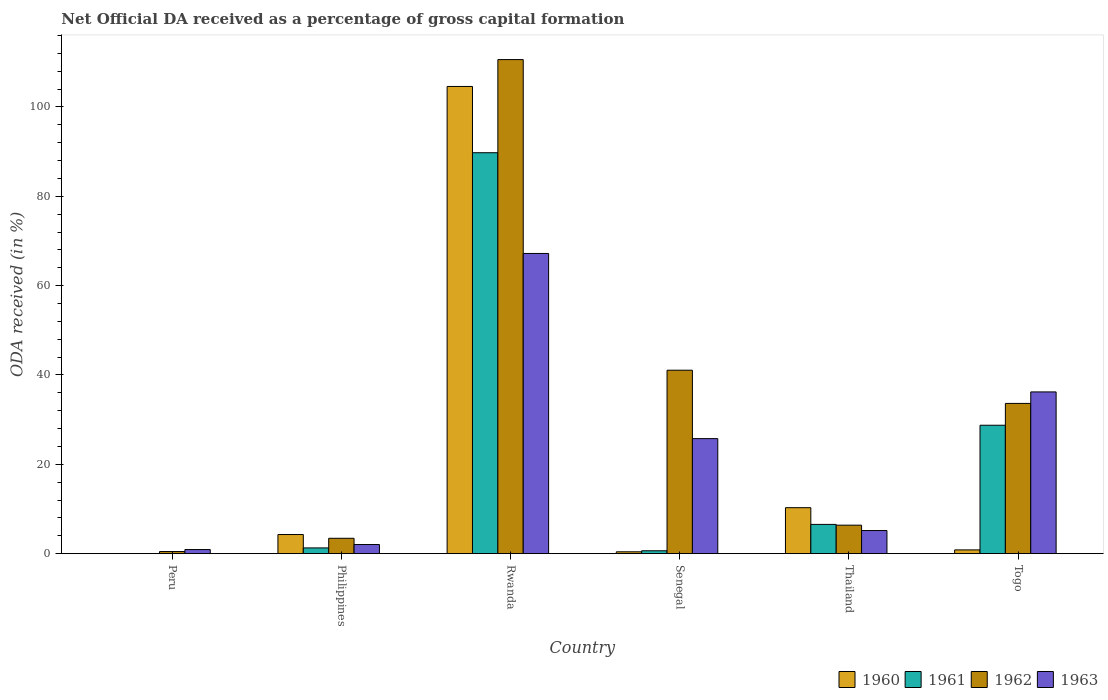How many different coloured bars are there?
Offer a very short reply. 4. How many bars are there on the 1st tick from the left?
Provide a short and direct response. 2. How many bars are there on the 5th tick from the right?
Give a very brief answer. 4. What is the label of the 5th group of bars from the left?
Ensure brevity in your answer.  Thailand. In how many cases, is the number of bars for a given country not equal to the number of legend labels?
Offer a terse response. 1. Across all countries, what is the maximum net ODA received in 1963?
Keep it short and to the point. 67.2. Across all countries, what is the minimum net ODA received in 1962?
Ensure brevity in your answer.  0.47. In which country was the net ODA received in 1960 maximum?
Offer a very short reply. Rwanda. What is the total net ODA received in 1963 in the graph?
Your response must be concise. 137.3. What is the difference between the net ODA received in 1963 in Peru and that in Thailand?
Your response must be concise. -4.26. What is the difference between the net ODA received in 1963 in Peru and the net ODA received in 1961 in Philippines?
Make the answer very short. -0.37. What is the average net ODA received in 1963 per country?
Provide a succinct answer. 22.88. What is the difference between the net ODA received of/in 1962 and net ODA received of/in 1963 in Thailand?
Ensure brevity in your answer.  1.2. What is the ratio of the net ODA received in 1963 in Philippines to that in Senegal?
Keep it short and to the point. 0.08. Is the net ODA received in 1961 in Thailand less than that in Togo?
Offer a terse response. Yes. Is the difference between the net ODA received in 1962 in Peru and Togo greater than the difference between the net ODA received in 1963 in Peru and Togo?
Offer a terse response. Yes. What is the difference between the highest and the second highest net ODA received in 1961?
Provide a succinct answer. 61.01. What is the difference between the highest and the lowest net ODA received in 1961?
Your answer should be compact. 89.75. Is it the case that in every country, the sum of the net ODA received in 1960 and net ODA received in 1962 is greater than the net ODA received in 1963?
Provide a succinct answer. No. Are all the bars in the graph horizontal?
Your answer should be compact. No. How many countries are there in the graph?
Give a very brief answer. 6. What is the difference between two consecutive major ticks on the Y-axis?
Your response must be concise. 20. Are the values on the major ticks of Y-axis written in scientific E-notation?
Your answer should be very brief. No. Does the graph contain any zero values?
Your response must be concise. Yes. Does the graph contain grids?
Give a very brief answer. No. Where does the legend appear in the graph?
Your answer should be very brief. Bottom right. How many legend labels are there?
Offer a terse response. 4. How are the legend labels stacked?
Your answer should be compact. Horizontal. What is the title of the graph?
Offer a terse response. Net Official DA received as a percentage of gross capital formation. What is the label or title of the X-axis?
Your answer should be compact. Country. What is the label or title of the Y-axis?
Offer a very short reply. ODA received (in %). What is the ODA received (in %) of 1960 in Peru?
Provide a short and direct response. 0. What is the ODA received (in %) of 1961 in Peru?
Your response must be concise. 0. What is the ODA received (in %) of 1962 in Peru?
Ensure brevity in your answer.  0.47. What is the ODA received (in %) of 1963 in Peru?
Provide a succinct answer. 0.92. What is the ODA received (in %) of 1960 in Philippines?
Your answer should be very brief. 4.28. What is the ODA received (in %) of 1961 in Philippines?
Give a very brief answer. 1.29. What is the ODA received (in %) of 1962 in Philippines?
Offer a terse response. 3.44. What is the ODA received (in %) in 1963 in Philippines?
Offer a terse response. 2.05. What is the ODA received (in %) of 1960 in Rwanda?
Keep it short and to the point. 104.58. What is the ODA received (in %) of 1961 in Rwanda?
Keep it short and to the point. 89.75. What is the ODA received (in %) of 1962 in Rwanda?
Provide a short and direct response. 110.6. What is the ODA received (in %) in 1963 in Rwanda?
Your answer should be compact. 67.2. What is the ODA received (in %) of 1960 in Senegal?
Your response must be concise. 0.42. What is the ODA received (in %) in 1961 in Senegal?
Offer a terse response. 0.65. What is the ODA received (in %) in 1962 in Senegal?
Your answer should be compact. 41.06. What is the ODA received (in %) of 1963 in Senegal?
Your answer should be compact. 25.75. What is the ODA received (in %) in 1960 in Thailand?
Offer a terse response. 10.29. What is the ODA received (in %) in 1961 in Thailand?
Your answer should be compact. 6.55. What is the ODA received (in %) of 1962 in Thailand?
Keep it short and to the point. 6.38. What is the ODA received (in %) of 1963 in Thailand?
Offer a very short reply. 5.18. What is the ODA received (in %) in 1960 in Togo?
Provide a short and direct response. 0.84. What is the ODA received (in %) in 1961 in Togo?
Make the answer very short. 28.74. What is the ODA received (in %) of 1962 in Togo?
Provide a short and direct response. 33.63. What is the ODA received (in %) of 1963 in Togo?
Make the answer very short. 36.21. Across all countries, what is the maximum ODA received (in %) in 1960?
Keep it short and to the point. 104.58. Across all countries, what is the maximum ODA received (in %) in 1961?
Offer a very short reply. 89.75. Across all countries, what is the maximum ODA received (in %) of 1962?
Your answer should be compact. 110.6. Across all countries, what is the maximum ODA received (in %) in 1963?
Provide a short and direct response. 67.2. Across all countries, what is the minimum ODA received (in %) of 1961?
Ensure brevity in your answer.  0. Across all countries, what is the minimum ODA received (in %) of 1962?
Your answer should be very brief. 0.47. Across all countries, what is the minimum ODA received (in %) in 1963?
Make the answer very short. 0.92. What is the total ODA received (in %) in 1960 in the graph?
Offer a terse response. 120.42. What is the total ODA received (in %) of 1961 in the graph?
Provide a short and direct response. 126.98. What is the total ODA received (in %) in 1962 in the graph?
Give a very brief answer. 195.59. What is the total ODA received (in %) of 1963 in the graph?
Offer a terse response. 137.3. What is the difference between the ODA received (in %) in 1962 in Peru and that in Philippines?
Ensure brevity in your answer.  -2.97. What is the difference between the ODA received (in %) of 1963 in Peru and that in Philippines?
Offer a very short reply. -1.13. What is the difference between the ODA received (in %) in 1962 in Peru and that in Rwanda?
Offer a terse response. -110.13. What is the difference between the ODA received (in %) of 1963 in Peru and that in Rwanda?
Your answer should be compact. -66.28. What is the difference between the ODA received (in %) of 1962 in Peru and that in Senegal?
Provide a succinct answer. -40.59. What is the difference between the ODA received (in %) in 1963 in Peru and that in Senegal?
Make the answer very short. -24.83. What is the difference between the ODA received (in %) in 1962 in Peru and that in Thailand?
Offer a very short reply. -5.91. What is the difference between the ODA received (in %) in 1963 in Peru and that in Thailand?
Offer a terse response. -4.26. What is the difference between the ODA received (in %) of 1962 in Peru and that in Togo?
Your answer should be compact. -33.16. What is the difference between the ODA received (in %) of 1963 in Peru and that in Togo?
Ensure brevity in your answer.  -35.29. What is the difference between the ODA received (in %) in 1960 in Philippines and that in Rwanda?
Provide a succinct answer. -100.3. What is the difference between the ODA received (in %) in 1961 in Philippines and that in Rwanda?
Keep it short and to the point. -88.46. What is the difference between the ODA received (in %) of 1962 in Philippines and that in Rwanda?
Give a very brief answer. -107.16. What is the difference between the ODA received (in %) of 1963 in Philippines and that in Rwanda?
Ensure brevity in your answer.  -65.15. What is the difference between the ODA received (in %) in 1960 in Philippines and that in Senegal?
Ensure brevity in your answer.  3.87. What is the difference between the ODA received (in %) of 1961 in Philippines and that in Senegal?
Make the answer very short. 0.64. What is the difference between the ODA received (in %) in 1962 in Philippines and that in Senegal?
Provide a short and direct response. -37.62. What is the difference between the ODA received (in %) of 1963 in Philippines and that in Senegal?
Ensure brevity in your answer.  -23.7. What is the difference between the ODA received (in %) of 1960 in Philippines and that in Thailand?
Provide a succinct answer. -6.01. What is the difference between the ODA received (in %) in 1961 in Philippines and that in Thailand?
Ensure brevity in your answer.  -5.26. What is the difference between the ODA received (in %) in 1962 in Philippines and that in Thailand?
Your answer should be compact. -2.94. What is the difference between the ODA received (in %) of 1963 in Philippines and that in Thailand?
Make the answer very short. -3.13. What is the difference between the ODA received (in %) in 1960 in Philippines and that in Togo?
Your response must be concise. 3.44. What is the difference between the ODA received (in %) in 1961 in Philippines and that in Togo?
Offer a very short reply. -27.46. What is the difference between the ODA received (in %) in 1962 in Philippines and that in Togo?
Ensure brevity in your answer.  -30.19. What is the difference between the ODA received (in %) in 1963 in Philippines and that in Togo?
Your response must be concise. -34.16. What is the difference between the ODA received (in %) of 1960 in Rwanda and that in Senegal?
Your response must be concise. 104.17. What is the difference between the ODA received (in %) of 1961 in Rwanda and that in Senegal?
Keep it short and to the point. 89.1. What is the difference between the ODA received (in %) of 1962 in Rwanda and that in Senegal?
Keep it short and to the point. 69.54. What is the difference between the ODA received (in %) in 1963 in Rwanda and that in Senegal?
Provide a succinct answer. 41.45. What is the difference between the ODA received (in %) of 1960 in Rwanda and that in Thailand?
Give a very brief answer. 94.29. What is the difference between the ODA received (in %) of 1961 in Rwanda and that in Thailand?
Provide a succinct answer. 83.2. What is the difference between the ODA received (in %) in 1962 in Rwanda and that in Thailand?
Give a very brief answer. 104.22. What is the difference between the ODA received (in %) in 1963 in Rwanda and that in Thailand?
Your answer should be compact. 62.02. What is the difference between the ODA received (in %) of 1960 in Rwanda and that in Togo?
Make the answer very short. 103.74. What is the difference between the ODA received (in %) of 1961 in Rwanda and that in Togo?
Your answer should be compact. 61.01. What is the difference between the ODA received (in %) in 1962 in Rwanda and that in Togo?
Your answer should be compact. 76.97. What is the difference between the ODA received (in %) of 1963 in Rwanda and that in Togo?
Your response must be concise. 30.99. What is the difference between the ODA received (in %) in 1960 in Senegal and that in Thailand?
Provide a succinct answer. -9.88. What is the difference between the ODA received (in %) in 1961 in Senegal and that in Thailand?
Ensure brevity in your answer.  -5.91. What is the difference between the ODA received (in %) in 1962 in Senegal and that in Thailand?
Provide a short and direct response. 34.68. What is the difference between the ODA received (in %) of 1963 in Senegal and that in Thailand?
Your answer should be very brief. 20.57. What is the difference between the ODA received (in %) of 1960 in Senegal and that in Togo?
Give a very brief answer. -0.43. What is the difference between the ODA received (in %) of 1961 in Senegal and that in Togo?
Make the answer very short. -28.1. What is the difference between the ODA received (in %) of 1962 in Senegal and that in Togo?
Provide a succinct answer. 7.43. What is the difference between the ODA received (in %) in 1963 in Senegal and that in Togo?
Your response must be concise. -10.46. What is the difference between the ODA received (in %) in 1960 in Thailand and that in Togo?
Offer a terse response. 9.45. What is the difference between the ODA received (in %) of 1961 in Thailand and that in Togo?
Your response must be concise. -22.19. What is the difference between the ODA received (in %) of 1962 in Thailand and that in Togo?
Ensure brevity in your answer.  -27.25. What is the difference between the ODA received (in %) in 1963 in Thailand and that in Togo?
Make the answer very short. -31.03. What is the difference between the ODA received (in %) in 1962 in Peru and the ODA received (in %) in 1963 in Philippines?
Give a very brief answer. -1.57. What is the difference between the ODA received (in %) in 1962 in Peru and the ODA received (in %) in 1963 in Rwanda?
Make the answer very short. -66.73. What is the difference between the ODA received (in %) in 1962 in Peru and the ODA received (in %) in 1963 in Senegal?
Ensure brevity in your answer.  -25.28. What is the difference between the ODA received (in %) of 1962 in Peru and the ODA received (in %) of 1963 in Thailand?
Make the answer very short. -4.7. What is the difference between the ODA received (in %) in 1962 in Peru and the ODA received (in %) in 1963 in Togo?
Provide a short and direct response. -35.73. What is the difference between the ODA received (in %) in 1960 in Philippines and the ODA received (in %) in 1961 in Rwanda?
Your response must be concise. -85.47. What is the difference between the ODA received (in %) in 1960 in Philippines and the ODA received (in %) in 1962 in Rwanda?
Offer a very short reply. -106.32. What is the difference between the ODA received (in %) of 1960 in Philippines and the ODA received (in %) of 1963 in Rwanda?
Offer a terse response. -62.92. What is the difference between the ODA received (in %) in 1961 in Philippines and the ODA received (in %) in 1962 in Rwanda?
Provide a short and direct response. -109.31. What is the difference between the ODA received (in %) in 1961 in Philippines and the ODA received (in %) in 1963 in Rwanda?
Offer a very short reply. -65.91. What is the difference between the ODA received (in %) of 1962 in Philippines and the ODA received (in %) of 1963 in Rwanda?
Provide a succinct answer. -63.76. What is the difference between the ODA received (in %) of 1960 in Philippines and the ODA received (in %) of 1961 in Senegal?
Offer a very short reply. 3.64. What is the difference between the ODA received (in %) of 1960 in Philippines and the ODA received (in %) of 1962 in Senegal?
Make the answer very short. -36.78. What is the difference between the ODA received (in %) in 1960 in Philippines and the ODA received (in %) in 1963 in Senegal?
Your answer should be compact. -21.47. What is the difference between the ODA received (in %) of 1961 in Philippines and the ODA received (in %) of 1962 in Senegal?
Offer a terse response. -39.78. What is the difference between the ODA received (in %) of 1961 in Philippines and the ODA received (in %) of 1963 in Senegal?
Your response must be concise. -24.46. What is the difference between the ODA received (in %) of 1962 in Philippines and the ODA received (in %) of 1963 in Senegal?
Ensure brevity in your answer.  -22.31. What is the difference between the ODA received (in %) of 1960 in Philippines and the ODA received (in %) of 1961 in Thailand?
Provide a succinct answer. -2.27. What is the difference between the ODA received (in %) of 1960 in Philippines and the ODA received (in %) of 1962 in Thailand?
Provide a short and direct response. -2.1. What is the difference between the ODA received (in %) in 1960 in Philippines and the ODA received (in %) in 1963 in Thailand?
Offer a very short reply. -0.89. What is the difference between the ODA received (in %) of 1961 in Philippines and the ODA received (in %) of 1962 in Thailand?
Offer a terse response. -5.09. What is the difference between the ODA received (in %) in 1961 in Philippines and the ODA received (in %) in 1963 in Thailand?
Give a very brief answer. -3.89. What is the difference between the ODA received (in %) in 1962 in Philippines and the ODA received (in %) in 1963 in Thailand?
Provide a succinct answer. -1.73. What is the difference between the ODA received (in %) in 1960 in Philippines and the ODA received (in %) in 1961 in Togo?
Make the answer very short. -24.46. What is the difference between the ODA received (in %) of 1960 in Philippines and the ODA received (in %) of 1962 in Togo?
Your answer should be compact. -29.35. What is the difference between the ODA received (in %) in 1960 in Philippines and the ODA received (in %) in 1963 in Togo?
Keep it short and to the point. -31.92. What is the difference between the ODA received (in %) in 1961 in Philippines and the ODA received (in %) in 1962 in Togo?
Offer a terse response. -32.35. What is the difference between the ODA received (in %) of 1961 in Philippines and the ODA received (in %) of 1963 in Togo?
Offer a terse response. -34.92. What is the difference between the ODA received (in %) of 1962 in Philippines and the ODA received (in %) of 1963 in Togo?
Your response must be concise. -32.77. What is the difference between the ODA received (in %) in 1960 in Rwanda and the ODA received (in %) in 1961 in Senegal?
Offer a very short reply. 103.94. What is the difference between the ODA received (in %) of 1960 in Rwanda and the ODA received (in %) of 1962 in Senegal?
Your answer should be very brief. 63.52. What is the difference between the ODA received (in %) of 1960 in Rwanda and the ODA received (in %) of 1963 in Senegal?
Give a very brief answer. 78.83. What is the difference between the ODA received (in %) of 1961 in Rwanda and the ODA received (in %) of 1962 in Senegal?
Give a very brief answer. 48.69. What is the difference between the ODA received (in %) of 1961 in Rwanda and the ODA received (in %) of 1963 in Senegal?
Give a very brief answer. 64. What is the difference between the ODA received (in %) in 1962 in Rwanda and the ODA received (in %) in 1963 in Senegal?
Make the answer very short. 84.85. What is the difference between the ODA received (in %) of 1960 in Rwanda and the ODA received (in %) of 1961 in Thailand?
Your answer should be compact. 98.03. What is the difference between the ODA received (in %) in 1960 in Rwanda and the ODA received (in %) in 1962 in Thailand?
Keep it short and to the point. 98.2. What is the difference between the ODA received (in %) in 1960 in Rwanda and the ODA received (in %) in 1963 in Thailand?
Your response must be concise. 99.41. What is the difference between the ODA received (in %) in 1961 in Rwanda and the ODA received (in %) in 1962 in Thailand?
Give a very brief answer. 83.37. What is the difference between the ODA received (in %) of 1961 in Rwanda and the ODA received (in %) of 1963 in Thailand?
Make the answer very short. 84.57. What is the difference between the ODA received (in %) of 1962 in Rwanda and the ODA received (in %) of 1963 in Thailand?
Make the answer very short. 105.42. What is the difference between the ODA received (in %) in 1960 in Rwanda and the ODA received (in %) in 1961 in Togo?
Your answer should be very brief. 75.84. What is the difference between the ODA received (in %) of 1960 in Rwanda and the ODA received (in %) of 1962 in Togo?
Your answer should be compact. 70.95. What is the difference between the ODA received (in %) of 1960 in Rwanda and the ODA received (in %) of 1963 in Togo?
Your answer should be compact. 68.38. What is the difference between the ODA received (in %) of 1961 in Rwanda and the ODA received (in %) of 1962 in Togo?
Your response must be concise. 56.12. What is the difference between the ODA received (in %) in 1961 in Rwanda and the ODA received (in %) in 1963 in Togo?
Make the answer very short. 53.54. What is the difference between the ODA received (in %) of 1962 in Rwanda and the ODA received (in %) of 1963 in Togo?
Ensure brevity in your answer.  74.39. What is the difference between the ODA received (in %) of 1960 in Senegal and the ODA received (in %) of 1961 in Thailand?
Your answer should be compact. -6.13. What is the difference between the ODA received (in %) in 1960 in Senegal and the ODA received (in %) in 1962 in Thailand?
Provide a short and direct response. -5.96. What is the difference between the ODA received (in %) of 1960 in Senegal and the ODA received (in %) of 1963 in Thailand?
Provide a succinct answer. -4.76. What is the difference between the ODA received (in %) in 1961 in Senegal and the ODA received (in %) in 1962 in Thailand?
Your answer should be compact. -5.73. What is the difference between the ODA received (in %) of 1961 in Senegal and the ODA received (in %) of 1963 in Thailand?
Your answer should be compact. -4.53. What is the difference between the ODA received (in %) of 1962 in Senegal and the ODA received (in %) of 1963 in Thailand?
Keep it short and to the point. 35.89. What is the difference between the ODA received (in %) in 1960 in Senegal and the ODA received (in %) in 1961 in Togo?
Give a very brief answer. -28.33. What is the difference between the ODA received (in %) in 1960 in Senegal and the ODA received (in %) in 1962 in Togo?
Make the answer very short. -33.22. What is the difference between the ODA received (in %) in 1960 in Senegal and the ODA received (in %) in 1963 in Togo?
Make the answer very short. -35.79. What is the difference between the ODA received (in %) in 1961 in Senegal and the ODA received (in %) in 1962 in Togo?
Provide a short and direct response. -32.99. What is the difference between the ODA received (in %) of 1961 in Senegal and the ODA received (in %) of 1963 in Togo?
Your answer should be very brief. -35.56. What is the difference between the ODA received (in %) of 1962 in Senegal and the ODA received (in %) of 1963 in Togo?
Ensure brevity in your answer.  4.86. What is the difference between the ODA received (in %) in 1960 in Thailand and the ODA received (in %) in 1961 in Togo?
Ensure brevity in your answer.  -18.45. What is the difference between the ODA received (in %) in 1960 in Thailand and the ODA received (in %) in 1962 in Togo?
Offer a terse response. -23.34. What is the difference between the ODA received (in %) in 1960 in Thailand and the ODA received (in %) in 1963 in Togo?
Ensure brevity in your answer.  -25.91. What is the difference between the ODA received (in %) of 1961 in Thailand and the ODA received (in %) of 1962 in Togo?
Give a very brief answer. -27.08. What is the difference between the ODA received (in %) in 1961 in Thailand and the ODA received (in %) in 1963 in Togo?
Offer a terse response. -29.66. What is the difference between the ODA received (in %) in 1962 in Thailand and the ODA received (in %) in 1963 in Togo?
Your answer should be very brief. -29.83. What is the average ODA received (in %) of 1960 per country?
Offer a very short reply. 20.07. What is the average ODA received (in %) of 1961 per country?
Offer a very short reply. 21.16. What is the average ODA received (in %) of 1962 per country?
Make the answer very short. 32.6. What is the average ODA received (in %) of 1963 per country?
Make the answer very short. 22.88. What is the difference between the ODA received (in %) of 1962 and ODA received (in %) of 1963 in Peru?
Keep it short and to the point. -0.44. What is the difference between the ODA received (in %) in 1960 and ODA received (in %) in 1961 in Philippines?
Offer a very short reply. 3. What is the difference between the ODA received (in %) in 1960 and ODA received (in %) in 1962 in Philippines?
Offer a terse response. 0.84. What is the difference between the ODA received (in %) of 1960 and ODA received (in %) of 1963 in Philippines?
Your response must be concise. 2.24. What is the difference between the ODA received (in %) of 1961 and ODA received (in %) of 1962 in Philippines?
Make the answer very short. -2.15. What is the difference between the ODA received (in %) of 1961 and ODA received (in %) of 1963 in Philippines?
Offer a very short reply. -0.76. What is the difference between the ODA received (in %) of 1962 and ODA received (in %) of 1963 in Philippines?
Offer a very short reply. 1.4. What is the difference between the ODA received (in %) in 1960 and ODA received (in %) in 1961 in Rwanda?
Make the answer very short. 14.83. What is the difference between the ODA received (in %) of 1960 and ODA received (in %) of 1962 in Rwanda?
Make the answer very short. -6.02. What is the difference between the ODA received (in %) in 1960 and ODA received (in %) in 1963 in Rwanda?
Ensure brevity in your answer.  37.38. What is the difference between the ODA received (in %) in 1961 and ODA received (in %) in 1962 in Rwanda?
Your answer should be compact. -20.85. What is the difference between the ODA received (in %) in 1961 and ODA received (in %) in 1963 in Rwanda?
Offer a very short reply. 22.55. What is the difference between the ODA received (in %) in 1962 and ODA received (in %) in 1963 in Rwanda?
Provide a short and direct response. 43.4. What is the difference between the ODA received (in %) in 1960 and ODA received (in %) in 1961 in Senegal?
Your answer should be very brief. -0.23. What is the difference between the ODA received (in %) in 1960 and ODA received (in %) in 1962 in Senegal?
Make the answer very short. -40.65. What is the difference between the ODA received (in %) of 1960 and ODA received (in %) of 1963 in Senegal?
Provide a short and direct response. -25.33. What is the difference between the ODA received (in %) of 1961 and ODA received (in %) of 1962 in Senegal?
Offer a very short reply. -40.42. What is the difference between the ODA received (in %) in 1961 and ODA received (in %) in 1963 in Senegal?
Your answer should be very brief. -25.11. What is the difference between the ODA received (in %) of 1962 and ODA received (in %) of 1963 in Senegal?
Provide a succinct answer. 15.31. What is the difference between the ODA received (in %) in 1960 and ODA received (in %) in 1961 in Thailand?
Your response must be concise. 3.74. What is the difference between the ODA received (in %) in 1960 and ODA received (in %) in 1962 in Thailand?
Provide a short and direct response. 3.91. What is the difference between the ODA received (in %) in 1960 and ODA received (in %) in 1963 in Thailand?
Provide a short and direct response. 5.12. What is the difference between the ODA received (in %) in 1961 and ODA received (in %) in 1962 in Thailand?
Provide a succinct answer. 0.17. What is the difference between the ODA received (in %) in 1961 and ODA received (in %) in 1963 in Thailand?
Provide a short and direct response. 1.37. What is the difference between the ODA received (in %) in 1962 and ODA received (in %) in 1963 in Thailand?
Offer a very short reply. 1.2. What is the difference between the ODA received (in %) in 1960 and ODA received (in %) in 1961 in Togo?
Keep it short and to the point. -27.9. What is the difference between the ODA received (in %) in 1960 and ODA received (in %) in 1962 in Togo?
Provide a short and direct response. -32.79. What is the difference between the ODA received (in %) of 1960 and ODA received (in %) of 1963 in Togo?
Ensure brevity in your answer.  -35.37. What is the difference between the ODA received (in %) of 1961 and ODA received (in %) of 1962 in Togo?
Make the answer very short. -4.89. What is the difference between the ODA received (in %) of 1961 and ODA received (in %) of 1963 in Togo?
Your answer should be very brief. -7.46. What is the difference between the ODA received (in %) of 1962 and ODA received (in %) of 1963 in Togo?
Your answer should be very brief. -2.57. What is the ratio of the ODA received (in %) of 1962 in Peru to that in Philippines?
Your response must be concise. 0.14. What is the ratio of the ODA received (in %) in 1963 in Peru to that in Philippines?
Your response must be concise. 0.45. What is the ratio of the ODA received (in %) in 1962 in Peru to that in Rwanda?
Keep it short and to the point. 0. What is the ratio of the ODA received (in %) of 1963 in Peru to that in Rwanda?
Your response must be concise. 0.01. What is the ratio of the ODA received (in %) of 1962 in Peru to that in Senegal?
Give a very brief answer. 0.01. What is the ratio of the ODA received (in %) of 1963 in Peru to that in Senegal?
Your answer should be compact. 0.04. What is the ratio of the ODA received (in %) of 1962 in Peru to that in Thailand?
Provide a short and direct response. 0.07. What is the ratio of the ODA received (in %) in 1963 in Peru to that in Thailand?
Give a very brief answer. 0.18. What is the ratio of the ODA received (in %) in 1962 in Peru to that in Togo?
Provide a short and direct response. 0.01. What is the ratio of the ODA received (in %) of 1963 in Peru to that in Togo?
Keep it short and to the point. 0.03. What is the ratio of the ODA received (in %) in 1960 in Philippines to that in Rwanda?
Provide a succinct answer. 0.04. What is the ratio of the ODA received (in %) of 1961 in Philippines to that in Rwanda?
Offer a very short reply. 0.01. What is the ratio of the ODA received (in %) of 1962 in Philippines to that in Rwanda?
Provide a short and direct response. 0.03. What is the ratio of the ODA received (in %) of 1963 in Philippines to that in Rwanda?
Your answer should be compact. 0.03. What is the ratio of the ODA received (in %) in 1960 in Philippines to that in Senegal?
Your answer should be very brief. 10.3. What is the ratio of the ODA received (in %) of 1961 in Philippines to that in Senegal?
Offer a very short reply. 2. What is the ratio of the ODA received (in %) of 1962 in Philippines to that in Senegal?
Keep it short and to the point. 0.08. What is the ratio of the ODA received (in %) in 1963 in Philippines to that in Senegal?
Offer a very short reply. 0.08. What is the ratio of the ODA received (in %) of 1960 in Philippines to that in Thailand?
Keep it short and to the point. 0.42. What is the ratio of the ODA received (in %) in 1961 in Philippines to that in Thailand?
Make the answer very short. 0.2. What is the ratio of the ODA received (in %) in 1962 in Philippines to that in Thailand?
Provide a short and direct response. 0.54. What is the ratio of the ODA received (in %) in 1963 in Philippines to that in Thailand?
Offer a very short reply. 0.4. What is the ratio of the ODA received (in %) of 1960 in Philippines to that in Togo?
Keep it short and to the point. 5.08. What is the ratio of the ODA received (in %) of 1961 in Philippines to that in Togo?
Provide a short and direct response. 0.04. What is the ratio of the ODA received (in %) of 1962 in Philippines to that in Togo?
Your answer should be compact. 0.1. What is the ratio of the ODA received (in %) in 1963 in Philippines to that in Togo?
Your answer should be compact. 0.06. What is the ratio of the ODA received (in %) of 1960 in Rwanda to that in Senegal?
Your answer should be very brief. 251.36. What is the ratio of the ODA received (in %) of 1961 in Rwanda to that in Senegal?
Give a very brief answer. 139.13. What is the ratio of the ODA received (in %) of 1962 in Rwanda to that in Senegal?
Your answer should be very brief. 2.69. What is the ratio of the ODA received (in %) in 1963 in Rwanda to that in Senegal?
Provide a succinct answer. 2.61. What is the ratio of the ODA received (in %) of 1960 in Rwanda to that in Thailand?
Your answer should be very brief. 10.16. What is the ratio of the ODA received (in %) in 1961 in Rwanda to that in Thailand?
Provide a succinct answer. 13.7. What is the ratio of the ODA received (in %) of 1962 in Rwanda to that in Thailand?
Ensure brevity in your answer.  17.34. What is the ratio of the ODA received (in %) in 1963 in Rwanda to that in Thailand?
Provide a short and direct response. 12.98. What is the ratio of the ODA received (in %) of 1960 in Rwanda to that in Togo?
Give a very brief answer. 124.08. What is the ratio of the ODA received (in %) of 1961 in Rwanda to that in Togo?
Offer a terse response. 3.12. What is the ratio of the ODA received (in %) in 1962 in Rwanda to that in Togo?
Keep it short and to the point. 3.29. What is the ratio of the ODA received (in %) of 1963 in Rwanda to that in Togo?
Your response must be concise. 1.86. What is the ratio of the ODA received (in %) in 1960 in Senegal to that in Thailand?
Provide a succinct answer. 0.04. What is the ratio of the ODA received (in %) in 1961 in Senegal to that in Thailand?
Your answer should be compact. 0.1. What is the ratio of the ODA received (in %) in 1962 in Senegal to that in Thailand?
Your answer should be very brief. 6.44. What is the ratio of the ODA received (in %) of 1963 in Senegal to that in Thailand?
Offer a terse response. 4.97. What is the ratio of the ODA received (in %) in 1960 in Senegal to that in Togo?
Make the answer very short. 0.49. What is the ratio of the ODA received (in %) in 1961 in Senegal to that in Togo?
Offer a terse response. 0.02. What is the ratio of the ODA received (in %) in 1962 in Senegal to that in Togo?
Provide a succinct answer. 1.22. What is the ratio of the ODA received (in %) of 1963 in Senegal to that in Togo?
Provide a succinct answer. 0.71. What is the ratio of the ODA received (in %) of 1960 in Thailand to that in Togo?
Provide a succinct answer. 12.21. What is the ratio of the ODA received (in %) in 1961 in Thailand to that in Togo?
Make the answer very short. 0.23. What is the ratio of the ODA received (in %) of 1962 in Thailand to that in Togo?
Your answer should be compact. 0.19. What is the ratio of the ODA received (in %) of 1963 in Thailand to that in Togo?
Make the answer very short. 0.14. What is the difference between the highest and the second highest ODA received (in %) of 1960?
Your answer should be very brief. 94.29. What is the difference between the highest and the second highest ODA received (in %) of 1961?
Offer a very short reply. 61.01. What is the difference between the highest and the second highest ODA received (in %) of 1962?
Your answer should be very brief. 69.54. What is the difference between the highest and the second highest ODA received (in %) in 1963?
Give a very brief answer. 30.99. What is the difference between the highest and the lowest ODA received (in %) of 1960?
Keep it short and to the point. 104.58. What is the difference between the highest and the lowest ODA received (in %) in 1961?
Offer a very short reply. 89.75. What is the difference between the highest and the lowest ODA received (in %) of 1962?
Your response must be concise. 110.13. What is the difference between the highest and the lowest ODA received (in %) of 1963?
Offer a very short reply. 66.28. 